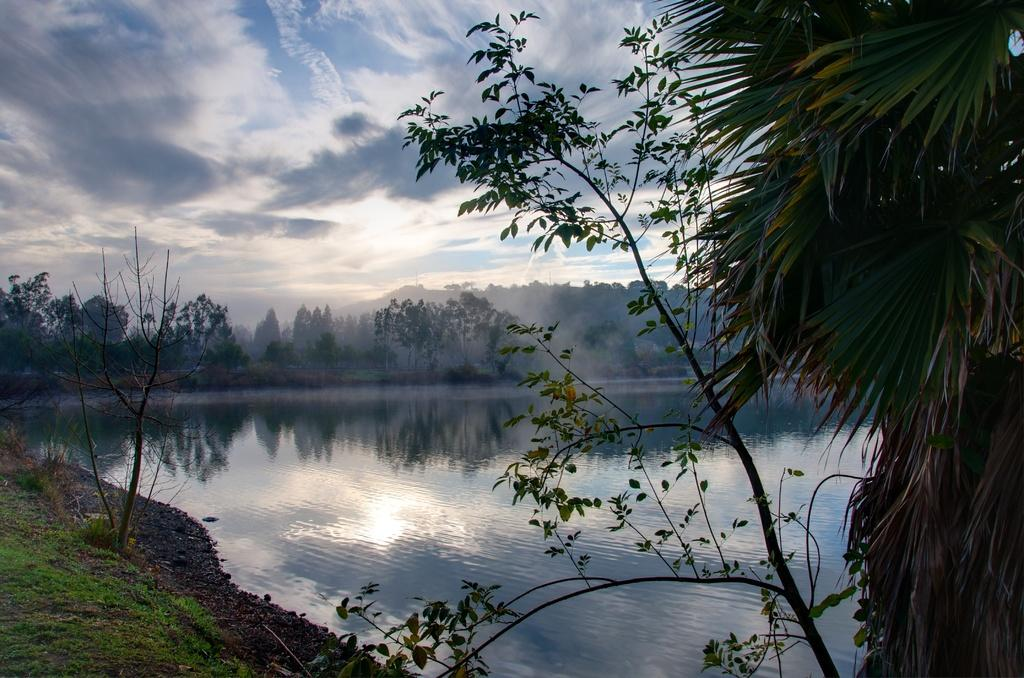What type of natural feature is present in the image? There is a river in the image. What can be seen in the river? The river water is visible in the image. What is located behind the river? There are trees behind the river. Can you identify a specific type of tree in the image? Yes, there is a coconut tree in the right corner of the image. What type of animal is attempting to climb the plate in the image? There is no animal or plate present in the image. 